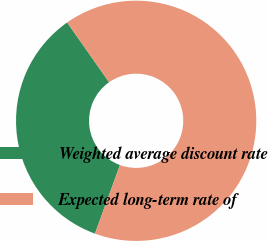Convert chart to OTSL. <chart><loc_0><loc_0><loc_500><loc_500><pie_chart><fcel>Weighted average discount rate<fcel>Expected long-term rate of<nl><fcel>34.69%<fcel>65.31%<nl></chart> 